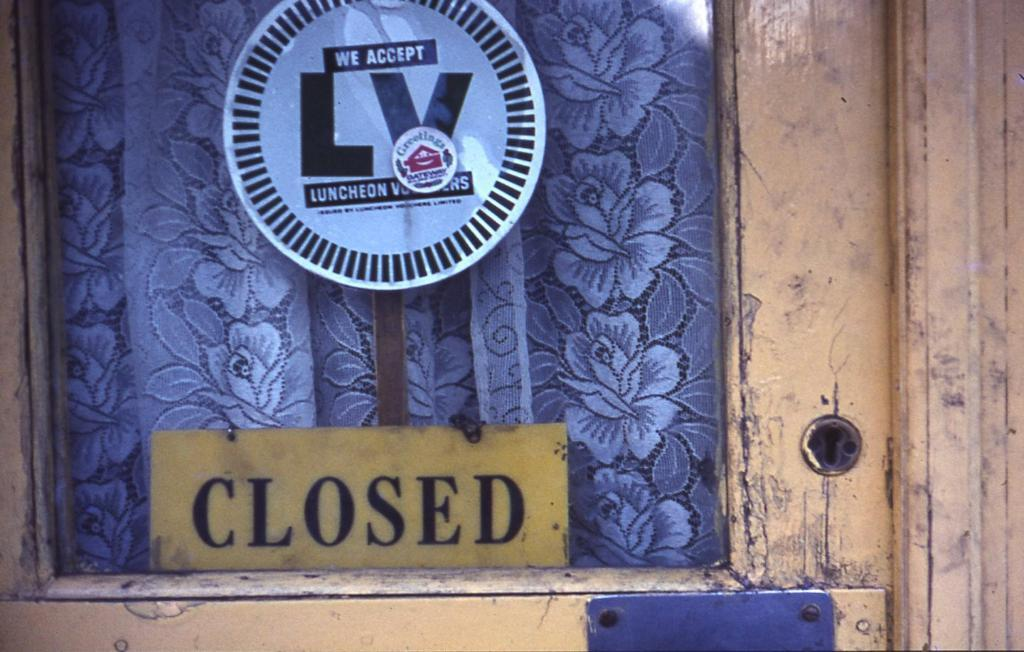Provide a one-sentence caption for the provided image. A yellow wooden door with a closed sign at the bottom of the glass. 